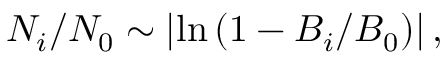Convert formula to latex. <formula><loc_0><loc_0><loc_500><loc_500>N _ { i } / N _ { 0 } \sim \left | \ln \left ( 1 - B _ { i } / B _ { 0 } \right ) \right | ,</formula> 